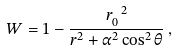Convert formula to latex. <formula><loc_0><loc_0><loc_500><loc_500>W = 1 - \frac { r _ { 0 } ^ { \ 2 } } { r ^ { 2 } + \alpha ^ { 2 } \cos ^ { 2 } \theta } \, ,</formula> 